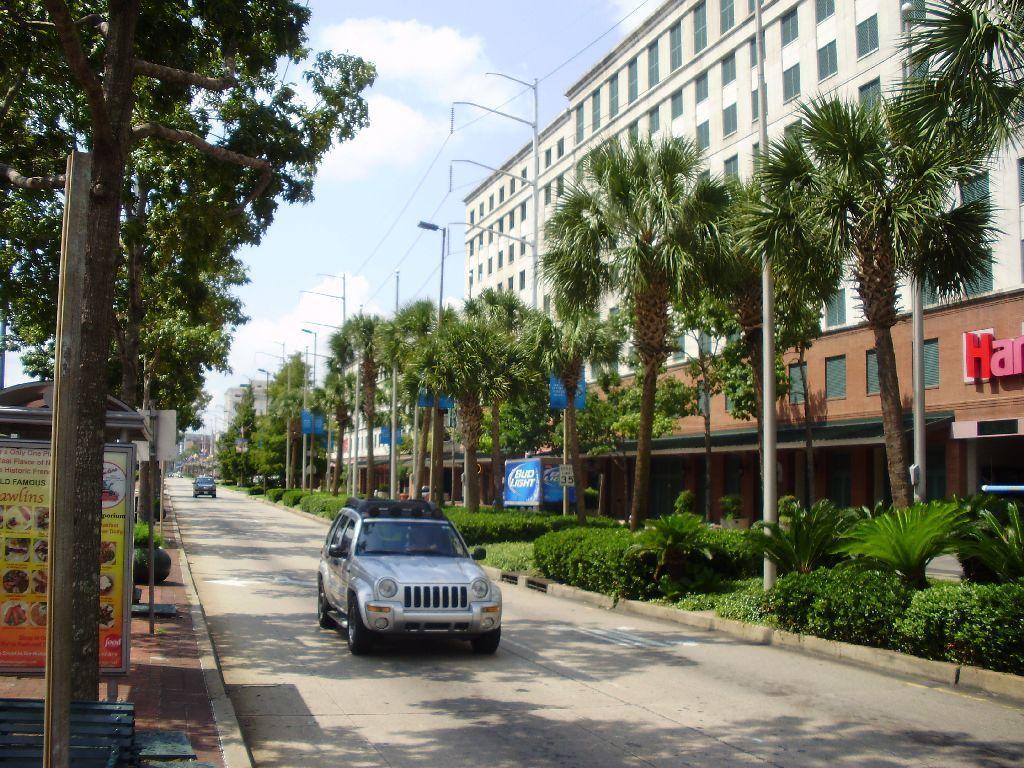How would you summarize this image in a sentence or two? In the image we can see there are cars parked on the road and there are plants and bushes on the ground. There are lot of trees and there are buildings. There are lot of trees and there is a cloudy sky. 